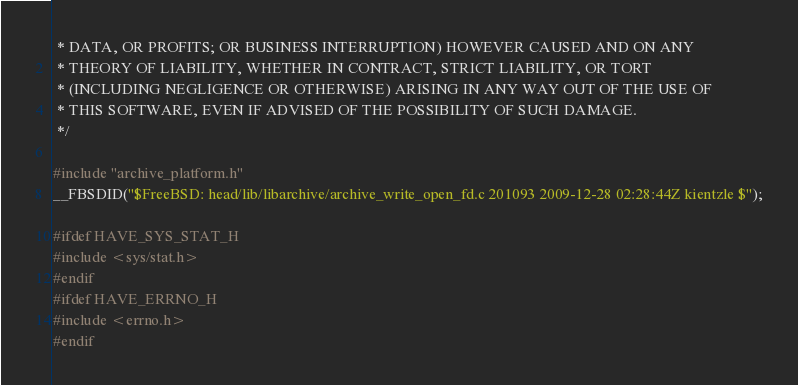Convert code to text. <code><loc_0><loc_0><loc_500><loc_500><_C_> * DATA, OR PROFITS; OR BUSINESS INTERRUPTION) HOWEVER CAUSED AND ON ANY
 * THEORY OF LIABILITY, WHETHER IN CONTRACT, STRICT LIABILITY, OR TORT
 * (INCLUDING NEGLIGENCE OR OTHERWISE) ARISING IN ANY WAY OUT OF THE USE OF
 * THIS SOFTWARE, EVEN IF ADVISED OF THE POSSIBILITY OF SUCH DAMAGE.
 */

#include "archive_platform.h"
__FBSDID("$FreeBSD: head/lib/libarchive/archive_write_open_fd.c 201093 2009-12-28 02:28:44Z kientzle $");

#ifdef HAVE_SYS_STAT_H
#include <sys/stat.h>
#endif
#ifdef HAVE_ERRNO_H
#include <errno.h>
#endif</code> 